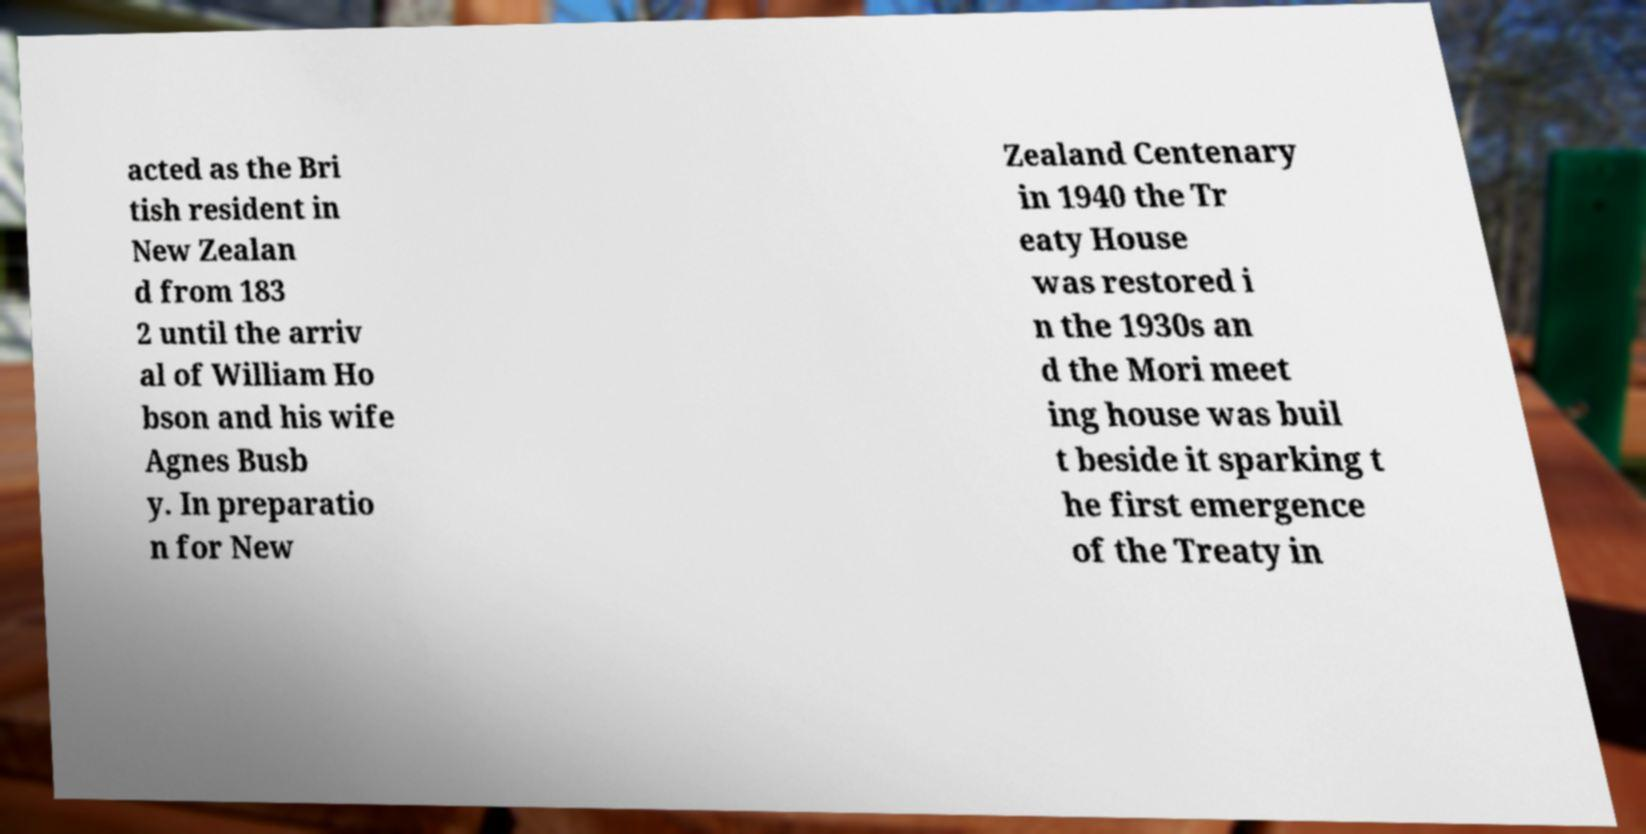Can you read and provide the text displayed in the image?This photo seems to have some interesting text. Can you extract and type it out for me? acted as the Bri tish resident in New Zealan d from 183 2 until the arriv al of William Ho bson and his wife Agnes Busb y. In preparatio n for New Zealand Centenary in 1940 the Tr eaty House was restored i n the 1930s an d the Mori meet ing house was buil t beside it sparking t he first emergence of the Treaty in 